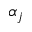<formula> <loc_0><loc_0><loc_500><loc_500>\alpha _ { j }</formula> 